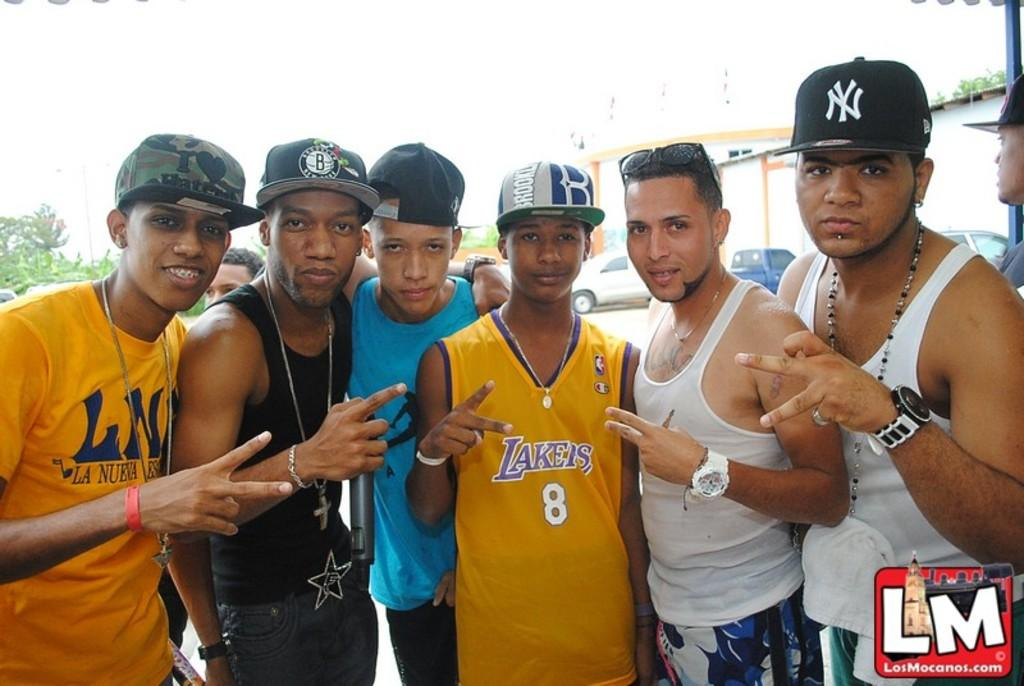What are the persons in the image wearing on their heads? The persons in the image are wearing caps. What is the position of the persons in the image? The persons are standing. What can be seen in the background of the image? There are trees, vehicles, buildings, and the sky visible in the background of the image. What type of bath can be seen in the image? There is no bath present in the image. What route are the persons taking in the image? The image does not show any route or direction of movement for the persons. 